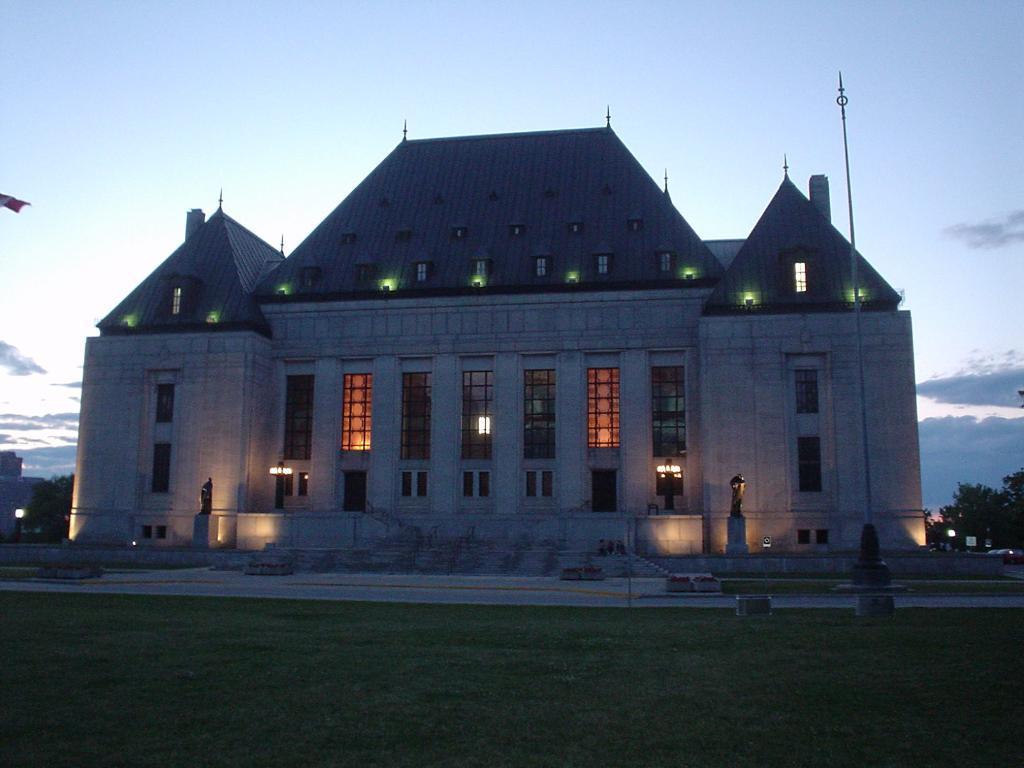How would you summarize this image in a sentence or two? In the center of the image there is a building. In front of the building there are statues. There are lights. In front of the image there is grass on the surface. There is a pole. In the background of the image there are trees and sky. 